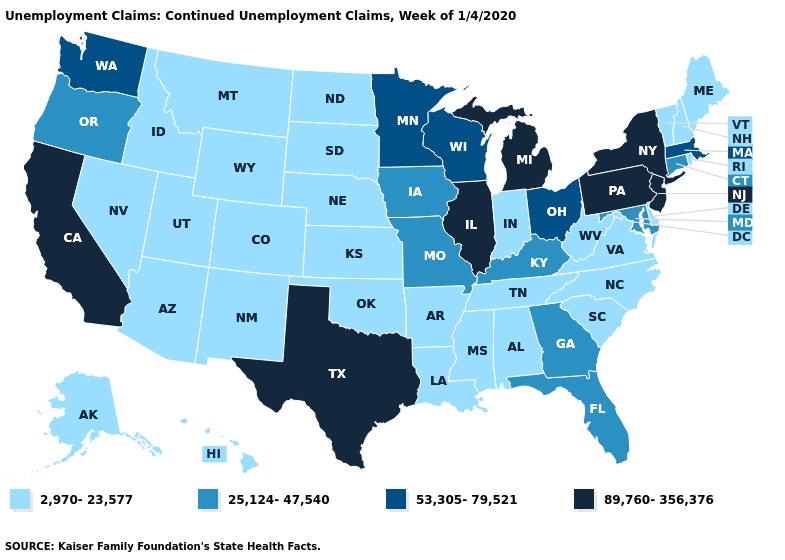Does the first symbol in the legend represent the smallest category?
Short answer required. Yes. What is the value of South Carolina?
Keep it brief. 2,970-23,577. Does South Dakota have a lower value than Arizona?
Give a very brief answer. No. Name the states that have a value in the range 53,305-79,521?
Be succinct. Massachusetts, Minnesota, Ohio, Washington, Wisconsin. What is the lowest value in the Northeast?
Quick response, please. 2,970-23,577. Does Utah have the highest value in the USA?
Write a very short answer. No. Is the legend a continuous bar?
Give a very brief answer. No. What is the value of Arizona?
Be succinct. 2,970-23,577. Name the states that have a value in the range 53,305-79,521?
Give a very brief answer. Massachusetts, Minnesota, Ohio, Washington, Wisconsin. What is the lowest value in the West?
Be succinct. 2,970-23,577. Does Connecticut have the lowest value in the Northeast?
Write a very short answer. No. What is the lowest value in the Northeast?
Keep it brief. 2,970-23,577. What is the value of Georgia?
Answer briefly. 25,124-47,540. Name the states that have a value in the range 2,970-23,577?
Quick response, please. Alabama, Alaska, Arizona, Arkansas, Colorado, Delaware, Hawaii, Idaho, Indiana, Kansas, Louisiana, Maine, Mississippi, Montana, Nebraska, Nevada, New Hampshire, New Mexico, North Carolina, North Dakota, Oklahoma, Rhode Island, South Carolina, South Dakota, Tennessee, Utah, Vermont, Virginia, West Virginia, Wyoming. How many symbols are there in the legend?
Answer briefly. 4. 